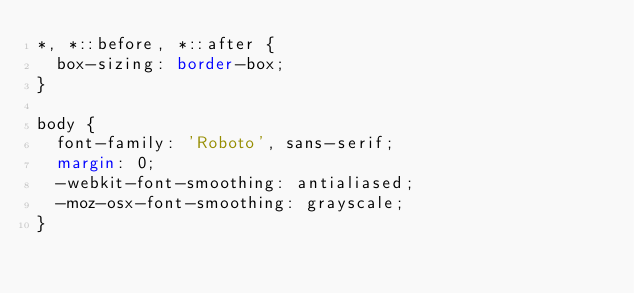Convert code to text. <code><loc_0><loc_0><loc_500><loc_500><_CSS_>*, *::before, *::after {
  box-sizing: border-box;
}

body {
  font-family: 'Roboto', sans-serif;
  margin: 0;
  -webkit-font-smoothing: antialiased;
  -moz-osx-font-smoothing: grayscale;
}
</code> 